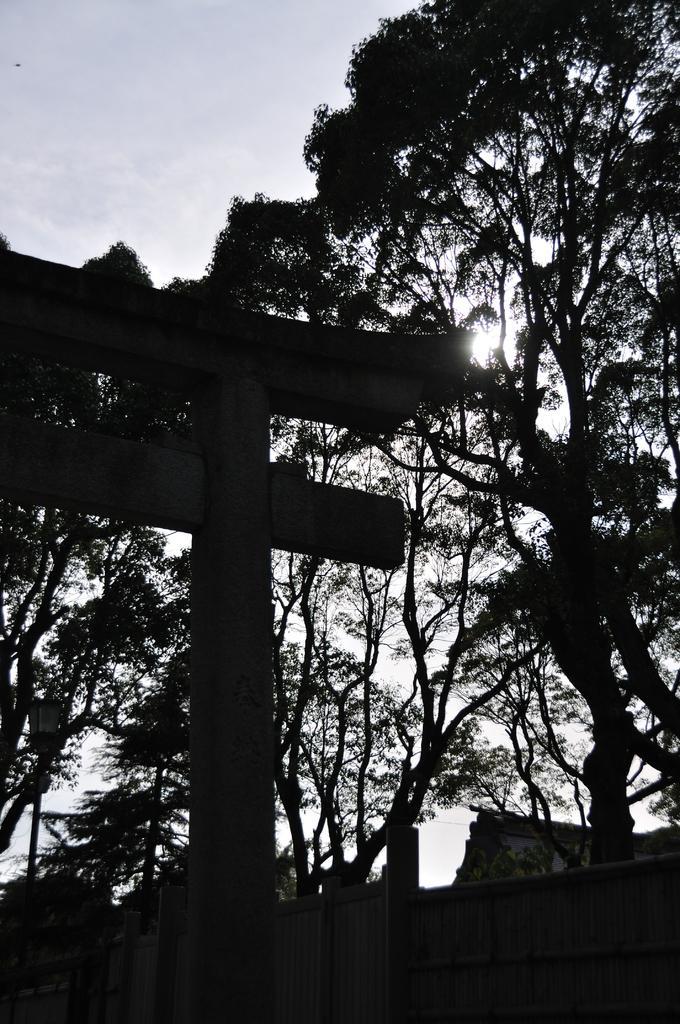Please provide a concise description of this image. In this image we can see a street sign to a pole. On the backside we can see a gate, a group of trees and the sky which looks cloudy. 